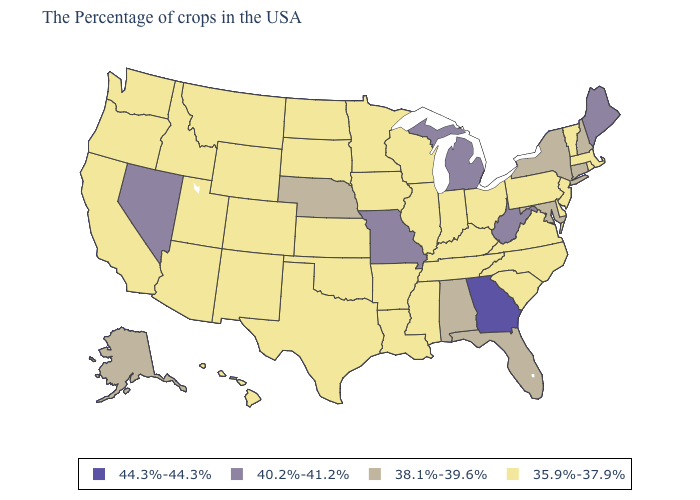What is the value of Nevada?
Keep it brief. 40.2%-41.2%. Among the states that border Oregon , which have the lowest value?
Answer briefly. Idaho, California, Washington. Name the states that have a value in the range 38.1%-39.6%?
Answer briefly. New Hampshire, Connecticut, New York, Maryland, Florida, Alabama, Nebraska, Alaska. Name the states that have a value in the range 44.3%-44.3%?
Short answer required. Georgia. Among the states that border California , which have the highest value?
Short answer required. Nevada. What is the lowest value in states that border Tennessee?
Write a very short answer. 35.9%-37.9%. What is the highest value in the USA?
Concise answer only. 44.3%-44.3%. What is the highest value in the South ?
Give a very brief answer. 44.3%-44.3%. What is the value of New Mexico?
Concise answer only. 35.9%-37.9%. Which states have the lowest value in the USA?
Short answer required. Massachusetts, Rhode Island, Vermont, New Jersey, Delaware, Pennsylvania, Virginia, North Carolina, South Carolina, Ohio, Kentucky, Indiana, Tennessee, Wisconsin, Illinois, Mississippi, Louisiana, Arkansas, Minnesota, Iowa, Kansas, Oklahoma, Texas, South Dakota, North Dakota, Wyoming, Colorado, New Mexico, Utah, Montana, Arizona, Idaho, California, Washington, Oregon, Hawaii. Among the states that border Ohio , does Indiana have the highest value?
Answer briefly. No. What is the lowest value in the MidWest?
Give a very brief answer. 35.9%-37.9%. Name the states that have a value in the range 35.9%-37.9%?
Keep it brief. Massachusetts, Rhode Island, Vermont, New Jersey, Delaware, Pennsylvania, Virginia, North Carolina, South Carolina, Ohio, Kentucky, Indiana, Tennessee, Wisconsin, Illinois, Mississippi, Louisiana, Arkansas, Minnesota, Iowa, Kansas, Oklahoma, Texas, South Dakota, North Dakota, Wyoming, Colorado, New Mexico, Utah, Montana, Arizona, Idaho, California, Washington, Oregon, Hawaii. Name the states that have a value in the range 35.9%-37.9%?
Be succinct. Massachusetts, Rhode Island, Vermont, New Jersey, Delaware, Pennsylvania, Virginia, North Carolina, South Carolina, Ohio, Kentucky, Indiana, Tennessee, Wisconsin, Illinois, Mississippi, Louisiana, Arkansas, Minnesota, Iowa, Kansas, Oklahoma, Texas, South Dakota, North Dakota, Wyoming, Colorado, New Mexico, Utah, Montana, Arizona, Idaho, California, Washington, Oregon, Hawaii. 